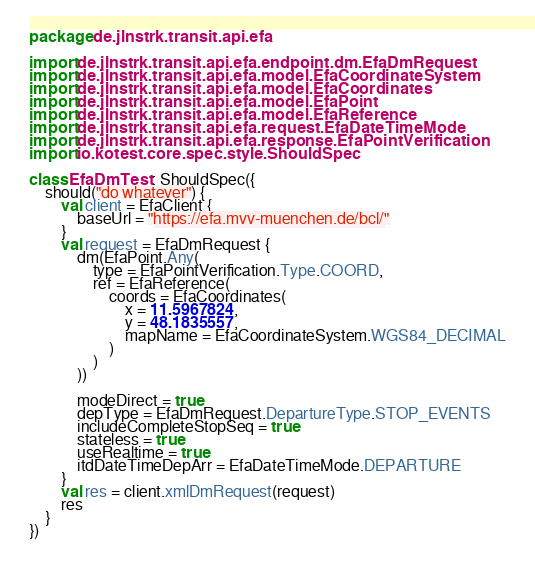<code> <loc_0><loc_0><loc_500><loc_500><_Kotlin_>package de.jlnstrk.transit.api.efa

import de.jlnstrk.transit.api.efa.endpoint.dm.EfaDmRequest
import de.jlnstrk.transit.api.efa.model.EfaCoordinateSystem
import de.jlnstrk.transit.api.efa.model.EfaCoordinates
import de.jlnstrk.transit.api.efa.model.EfaPoint
import de.jlnstrk.transit.api.efa.model.EfaReference
import de.jlnstrk.transit.api.efa.request.EfaDateTimeMode
import de.jlnstrk.transit.api.efa.response.EfaPointVerification
import io.kotest.core.spec.style.ShouldSpec

class EfaDmTest : ShouldSpec({
    should("do whatever") {
        val client = EfaClient {
            baseUrl = "https://efa.mvv-muenchen.de/bcl/"
        }
        val request = EfaDmRequest {
            dm(EfaPoint.Any(
                type = EfaPointVerification.Type.COORD,
                ref = EfaReference(
                    coords = EfaCoordinates(
                        x = 11.5967824,
                        y = 48.1835557,
                        mapName = EfaCoordinateSystem.WGS84_DECIMAL
                    )
                )
            ))

            modeDirect = true
            depType = EfaDmRequest.DepartureType.STOP_EVENTS
            includeCompleteStopSeq = true
            stateless = true
            useRealtime = true
            itdDateTimeDepArr = EfaDateTimeMode.DEPARTURE
        }
        val res = client.xmlDmRequest(request)
        res
    }
})</code> 